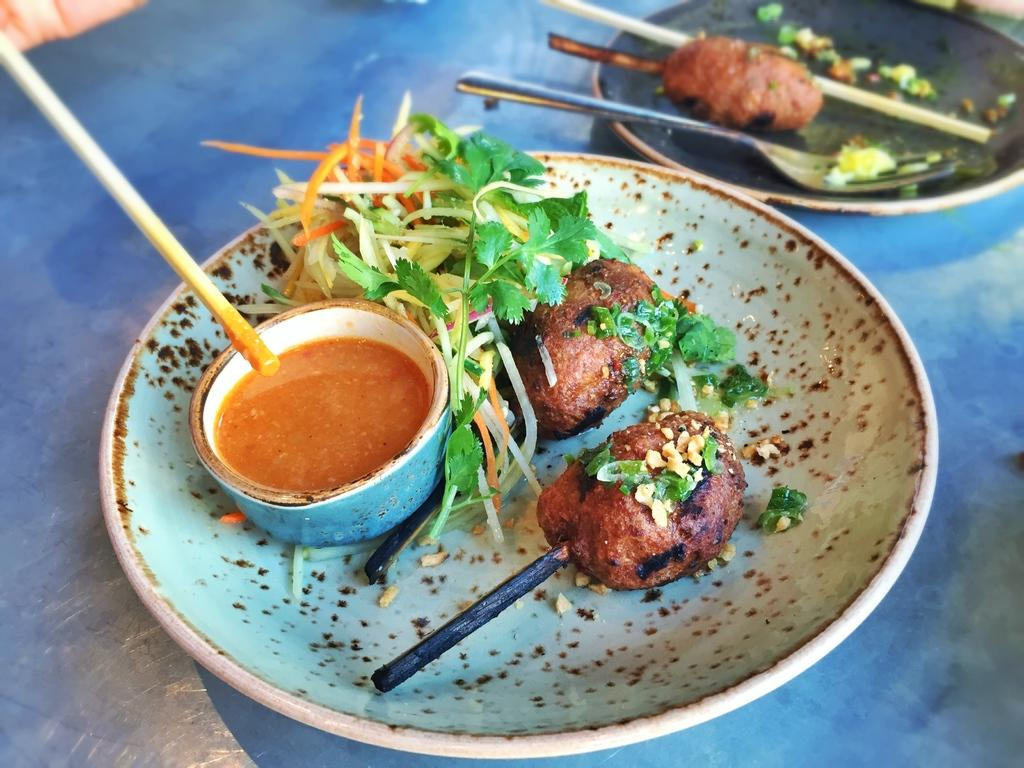What type of dishware can be seen in the image? There are plates and a bowl in the image. What utensils are present in the image? There are sticks (possibly chopsticks) and forks in the image. What is the main purpose of these utensils? The utensils are likely used for eating the food in the image. What is the surface that the plates, bowl, and utensils are placed on? The blue surface mentioned is likely a table or a similar surface. Can you see a nose on any of the plates in the image? No, there is no nose present on any of the plates in the image. Is there a ship visible in the image? No, there is no ship present in the image. 